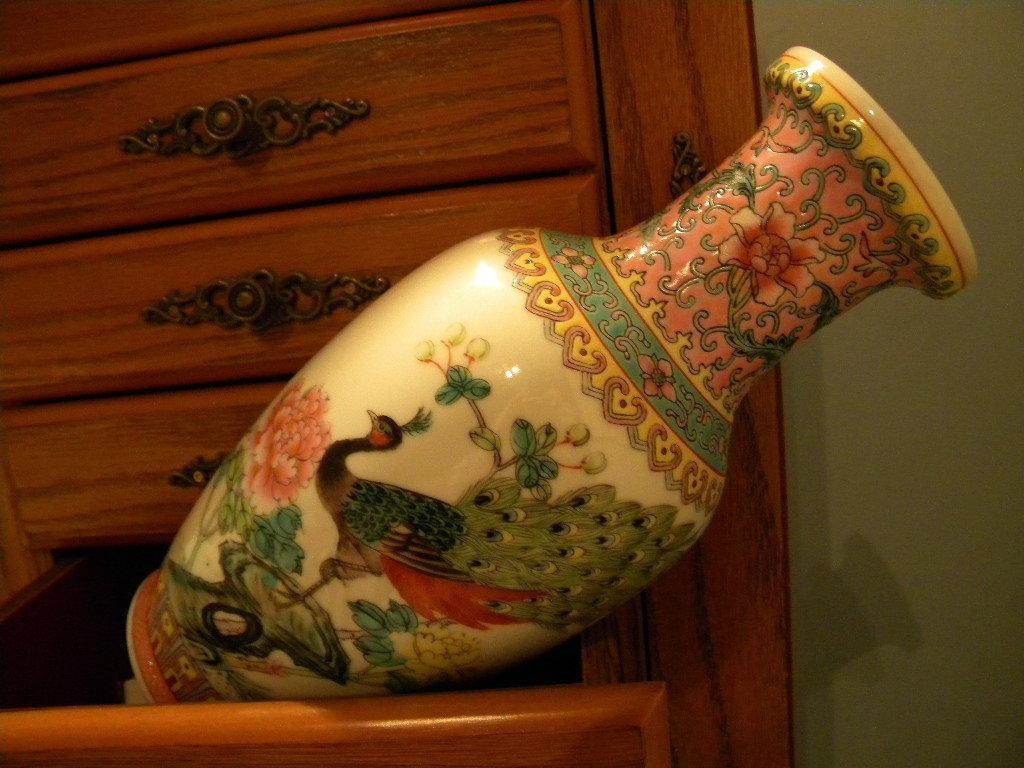Can you describe this image briefly? In the picture we can see a wooden drawers and one draw is opened in that we can see a flower pot with some designs and some paintings of a peacock on it, and beside it we can see a wall. 